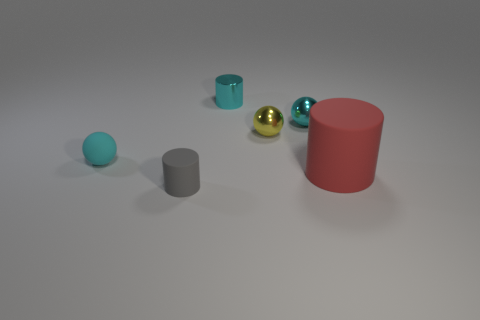The thing that is behind the tiny matte cylinder and left of the cyan shiny cylinder is what color?
Make the answer very short. Cyan. How many other objects are there of the same color as the large matte cylinder?
Your answer should be very brief. 0. What material is the small thing that is in front of the cylinder that is to the right of the small cyan metallic thing that is on the right side of the tiny yellow thing made of?
Make the answer very short. Rubber. How many spheres are cyan rubber things or gray objects?
Give a very brief answer. 1. Are there any other things that have the same size as the rubber sphere?
Offer a terse response. Yes. What number of cyan metallic objects are on the left side of the cyan ball that is to the right of the tiny cyan sphere that is left of the gray cylinder?
Keep it short and to the point. 1. Is the tiny cyan rubber object the same shape as the gray matte thing?
Give a very brief answer. No. Does the object in front of the large cylinder have the same material as the small cylinder behind the large rubber object?
Your answer should be compact. No. How many things are either cyan metal things that are on the right side of the yellow thing or small spheres on the right side of the metal cylinder?
Keep it short and to the point. 2. Are there any other things that are the same shape as the tiny yellow shiny thing?
Ensure brevity in your answer.  Yes. 